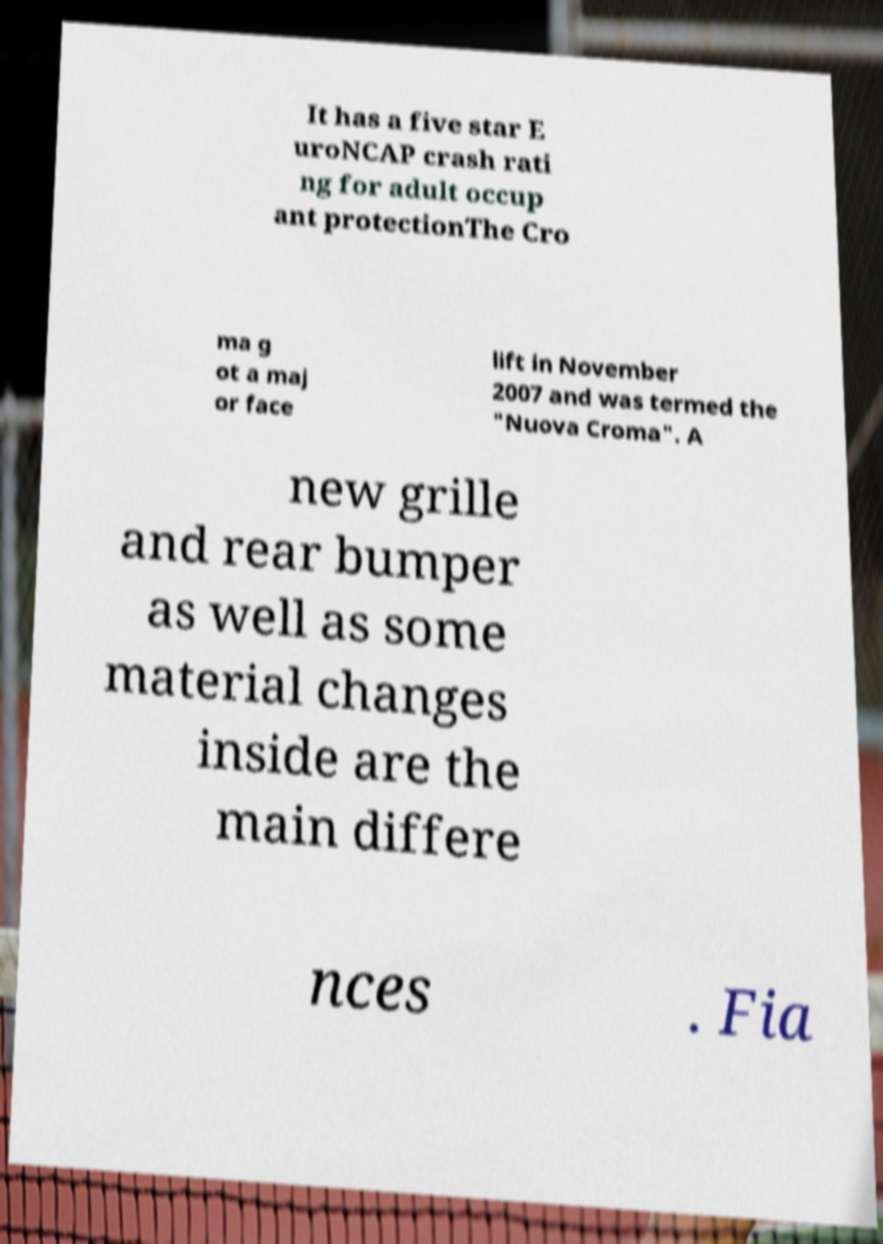Can you accurately transcribe the text from the provided image for me? It has a five star E uroNCAP crash rati ng for adult occup ant protectionThe Cro ma g ot a maj or face lift in November 2007 and was termed the "Nuova Croma". A new grille and rear bumper as well as some material changes inside are the main differe nces . Fia 